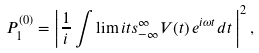<formula> <loc_0><loc_0><loc_500><loc_500>P _ { 1 } ^ { \left ( 0 \right ) } = \left | \frac { 1 } { i } \int \lim i t s _ { - \infty } ^ { \infty } V ( t ) \, e ^ { i \omega t } d t \, \right | ^ { 2 } ,</formula> 